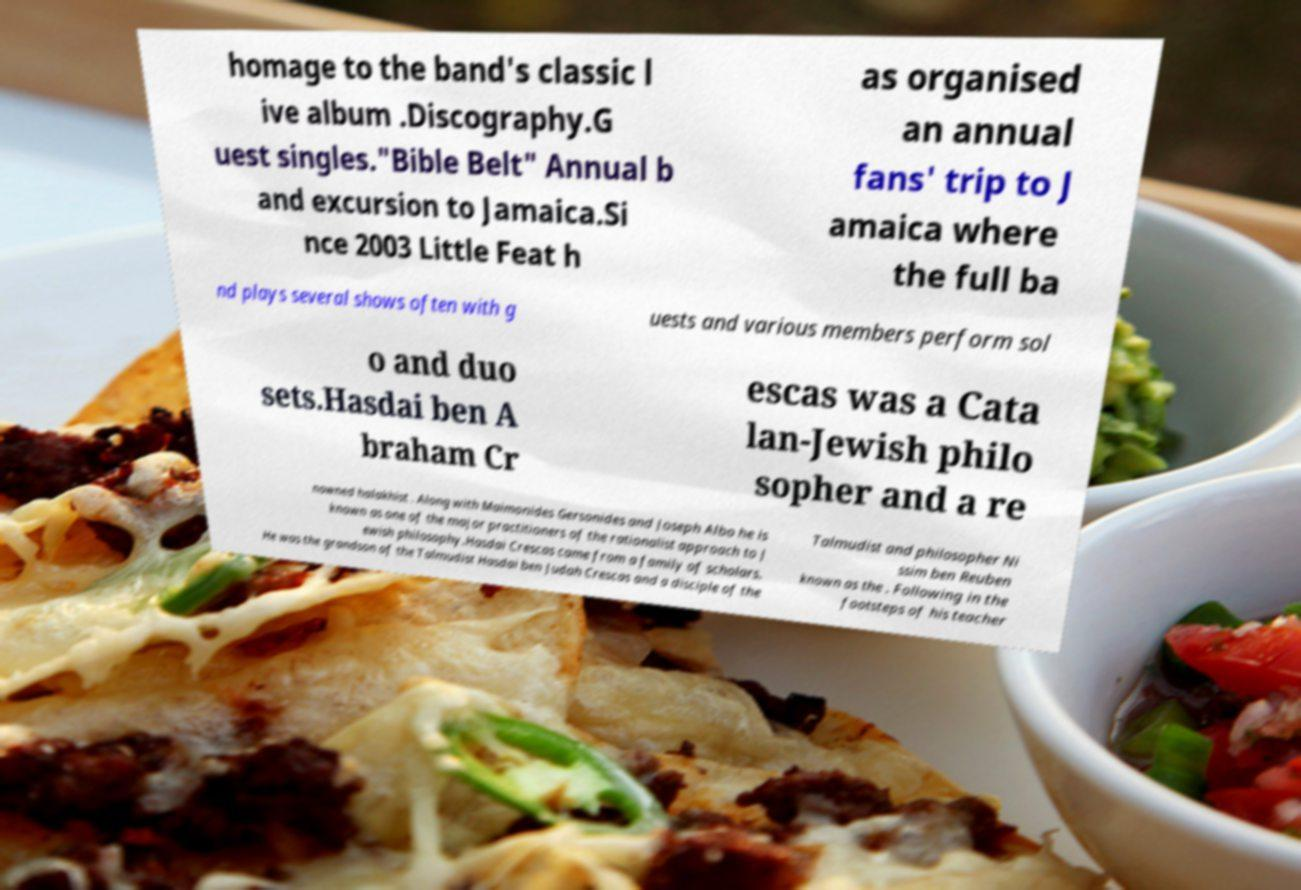Can you accurately transcribe the text from the provided image for me? homage to the band's classic l ive album .Discography.G uest singles."Bible Belt" Annual b and excursion to Jamaica.Si nce 2003 Little Feat h as organised an annual fans' trip to J amaica where the full ba nd plays several shows often with g uests and various members perform sol o and duo sets.Hasdai ben A braham Cr escas was a Cata lan-Jewish philo sopher and a re nowned halakhist . Along with Maimonides Gersonides and Joseph Albo he is known as one of the major practitioners of the rationalist approach to J ewish philosophy.Hasdai Crescas came from a family of scholars. He was the grandson of the Talmudist Hasdai ben Judah Crescas and a disciple of the Talmudist and philosopher Ni ssim ben Reuben known as the . Following in the footsteps of his teacher 